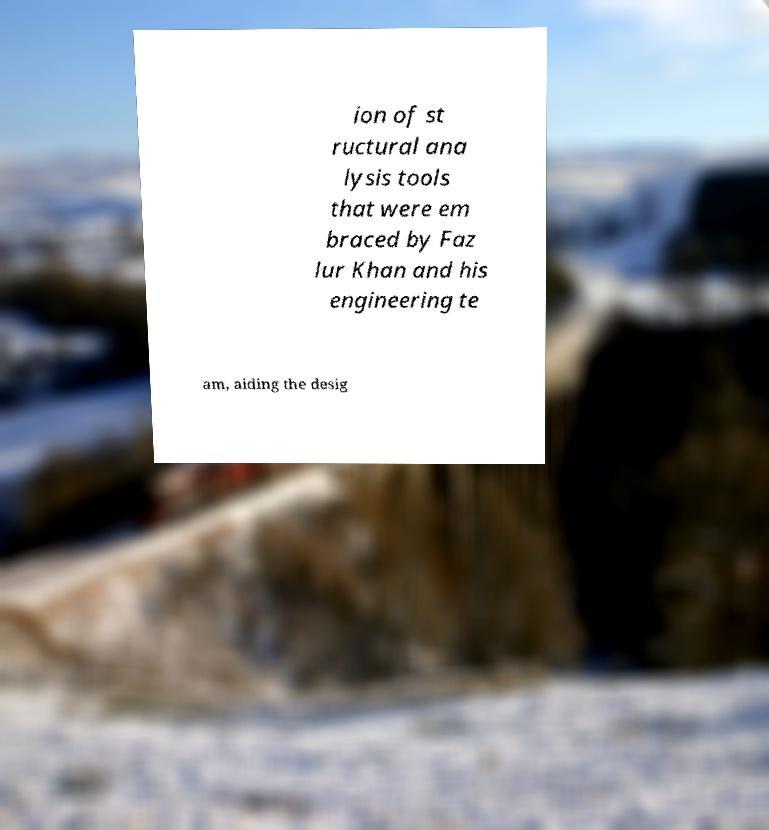What messages or text are displayed in this image? I need them in a readable, typed format. ion of st ructural ana lysis tools that were em braced by Faz lur Khan and his engineering te am, aiding the desig 